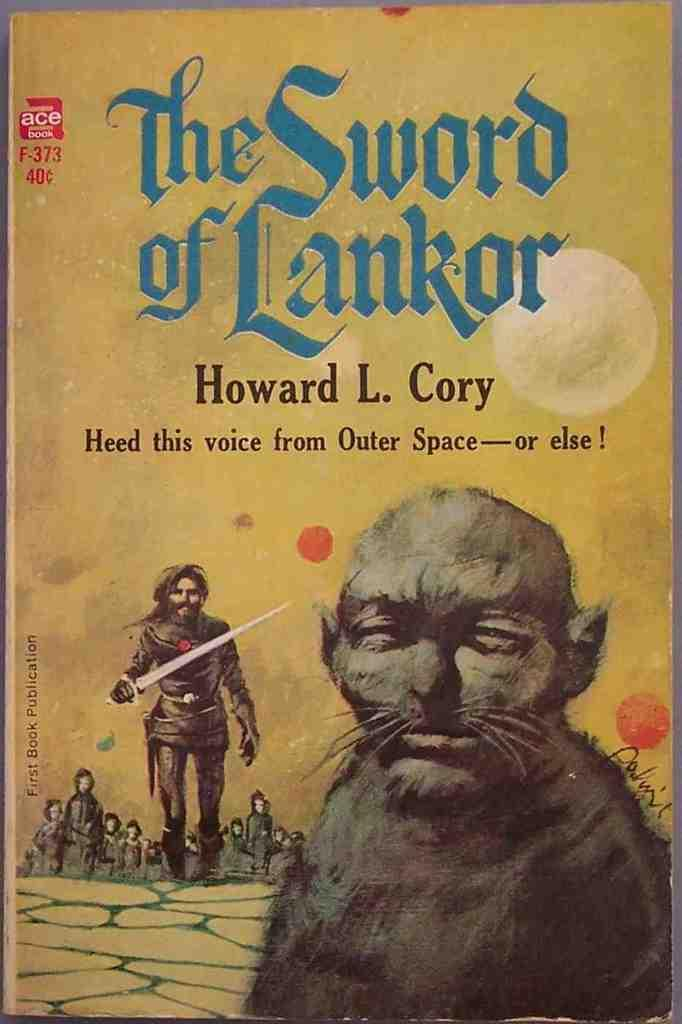Provide a one-sentence caption for the provided image. The book "The Sword of Lankor" by Howard L. Cory. 